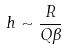<formula> <loc_0><loc_0><loc_500><loc_500>h \sim \frac { R } { Q \beta }</formula> 